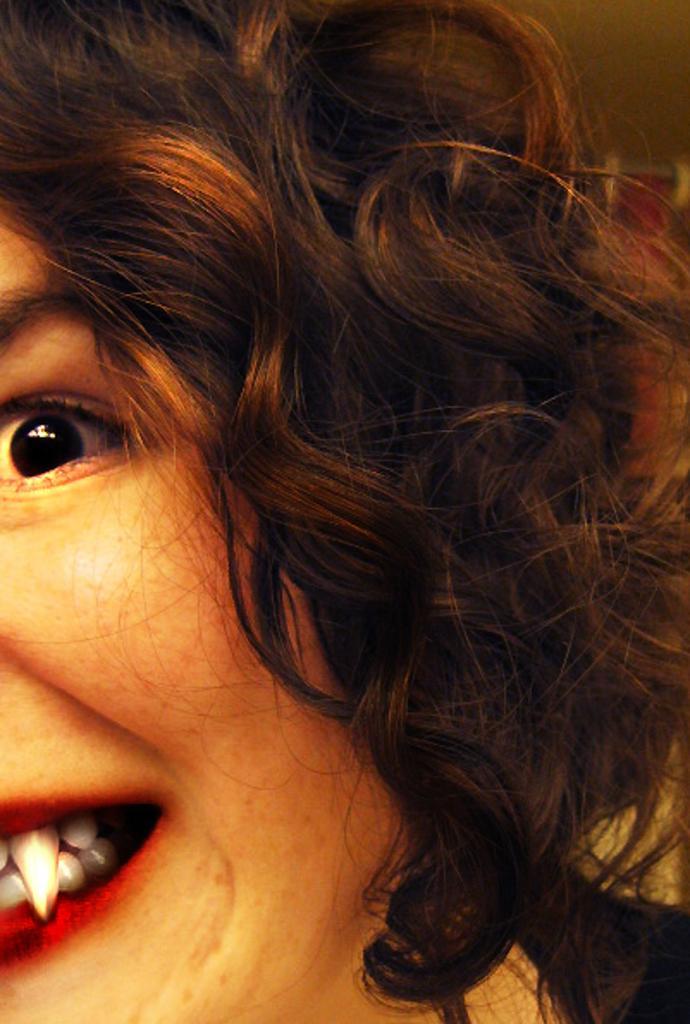Can you describe this image briefly? This image consists of a woman. 